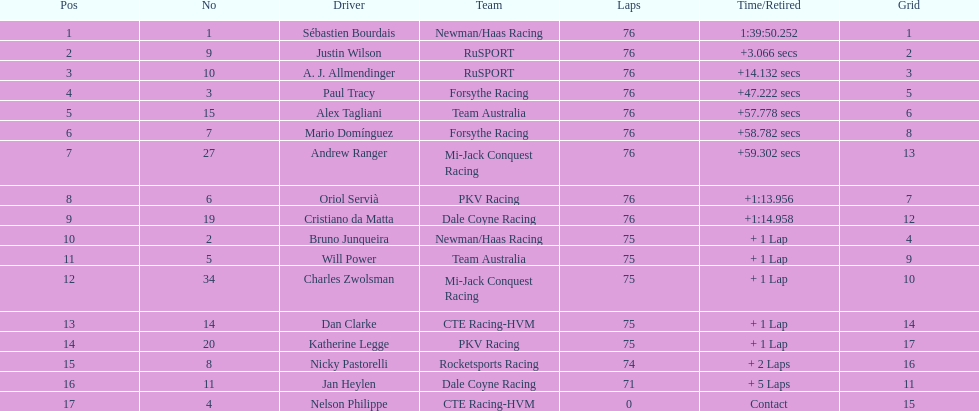How many positions are held by canada? 3. 